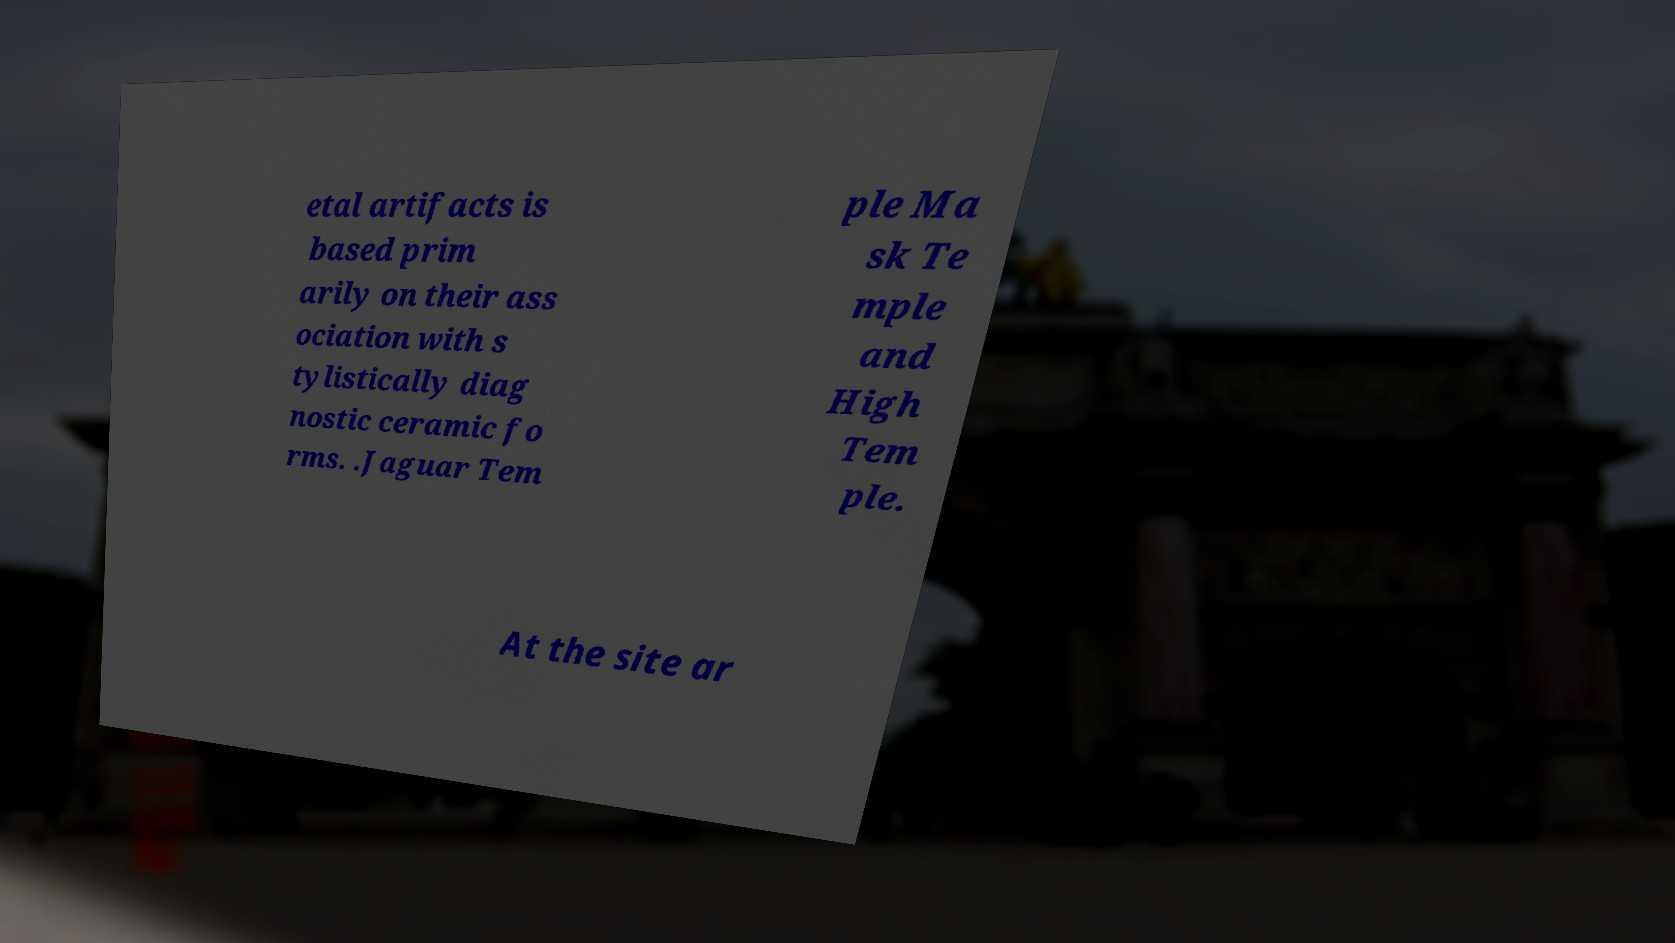Please identify and transcribe the text found in this image. etal artifacts is based prim arily on their ass ociation with s tylistically diag nostic ceramic fo rms. .Jaguar Tem ple Ma sk Te mple and High Tem ple. At the site ar 